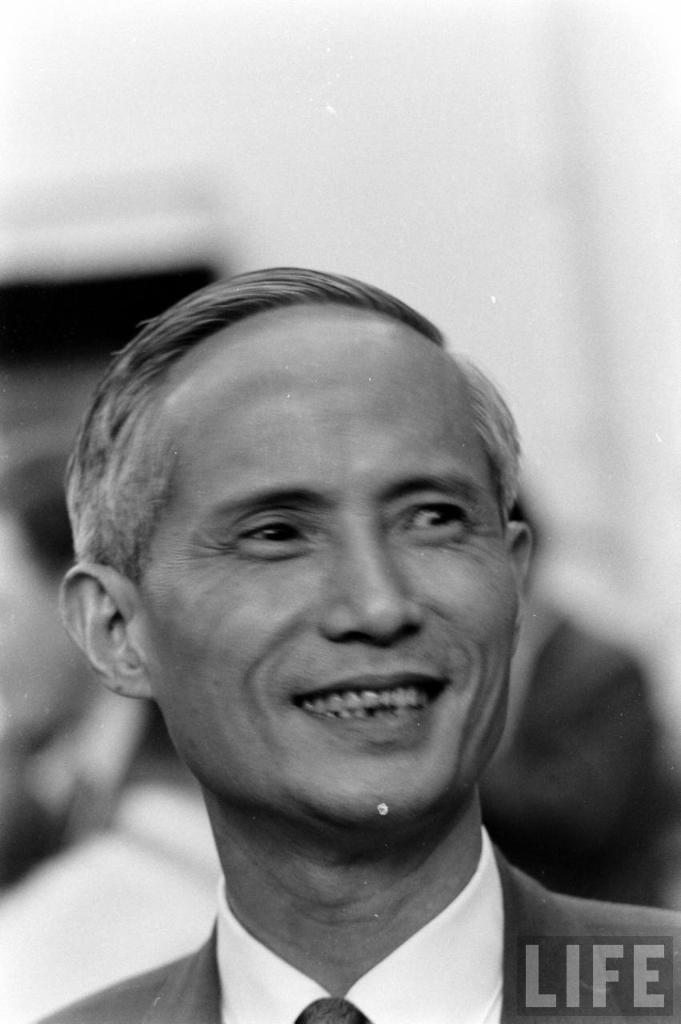What is the main subject in the center of the image? There is a man in the center of the image. Can you describe the people in the background of the image? There are people in the background of the image. What impulse did the man in the center of the image have to make him appear in the image? There is no information provided about the man's impulse or motivation for being in the image. How many minutes does the image capture? The image captures a single moment and does not have a duration in minutes. 